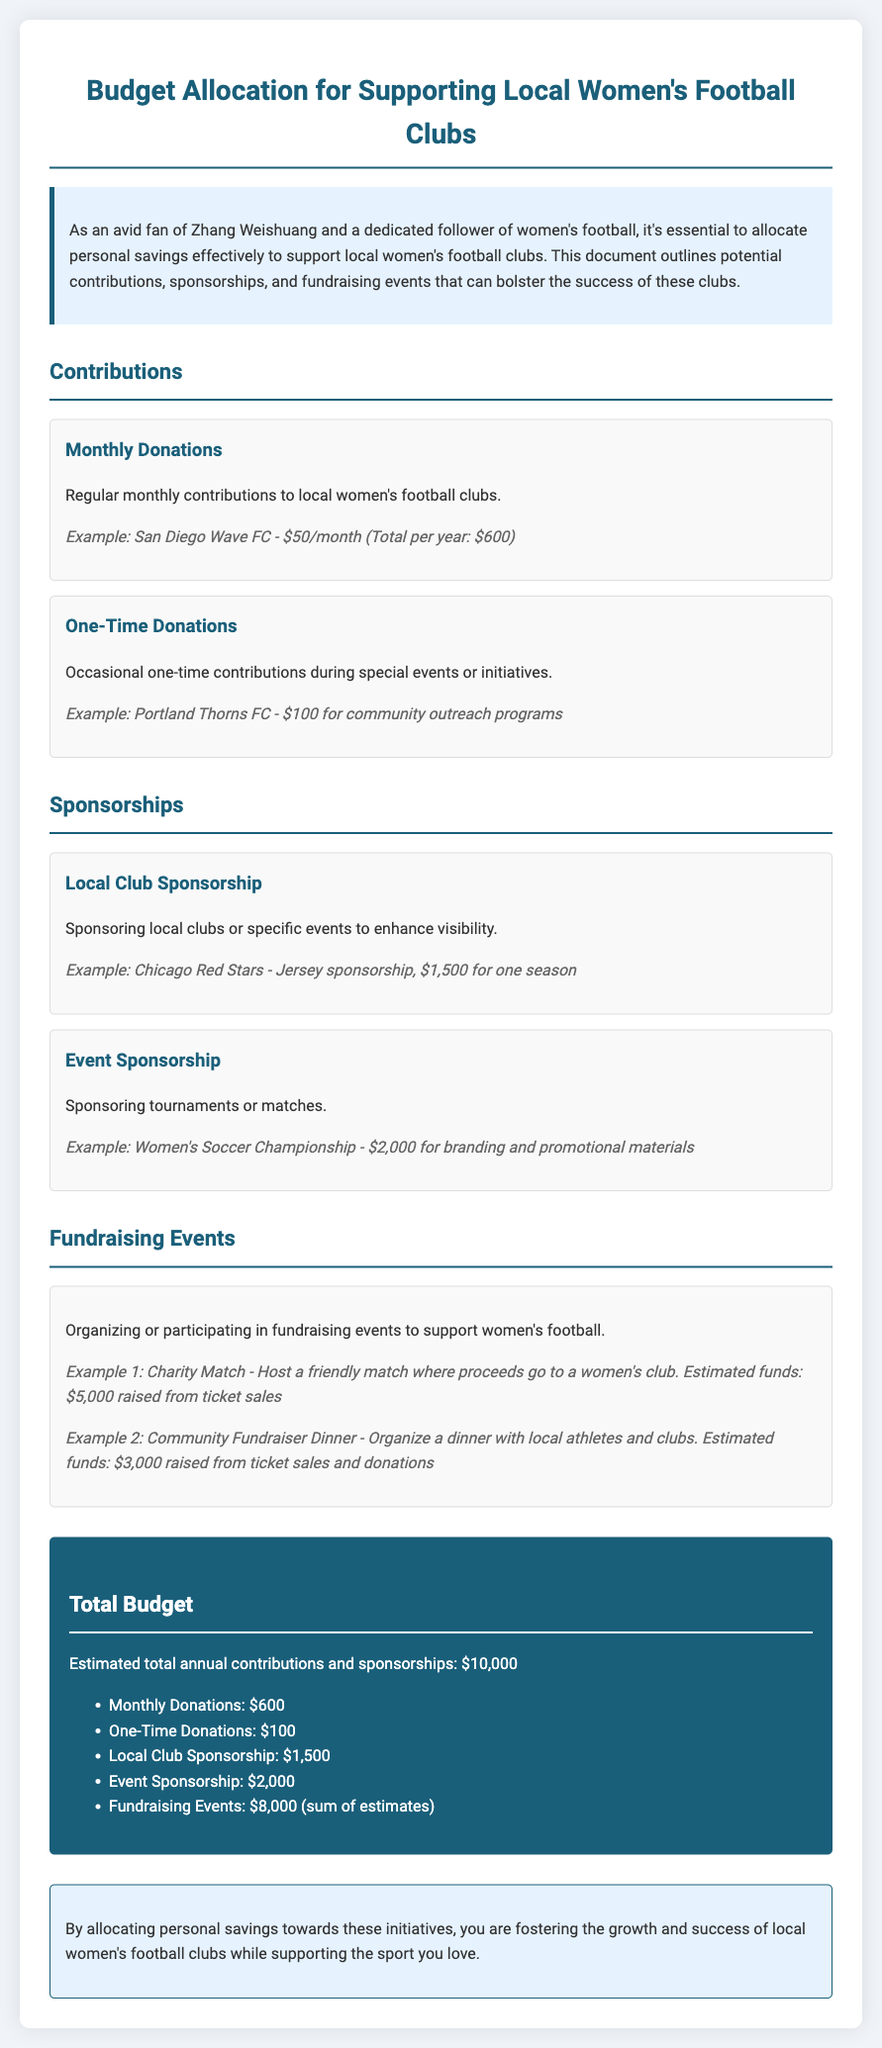What is the purpose of the document? The document outlines potential contributions, sponsorships, and fundraising events to support local women's football clubs.
Answer: Supporting local women's football clubs What is the example amount for monthly donations? The document provides an example of a monthly donation to San Diego Wave FC, which is $50/month.
Answer: $50/month How much is allocated for local club sponsorship? The budget item for local club sponsorship lists an example amount of $1,500 for one season for the Chicago Red Stars.
Answer: $1,500 What is the total estimated annual budget? The total budget section summarizes the total estimated contributions and sponsorships, which is $10,000.
Answer: $10,000 What is the fundraising estimate for a charity match? The document mentions that hosting a charity match could raise an estimated $5,000 from ticket sales.
Answer: $5,000 How much is budgeted for one-time donations? The section on contributions includes one-time donations with an example of $100 for community outreach programs.
Answer: $100 What are the two types of sponsorship mentioned? The sponsorship section specifies 'Local Club Sponsorship' and 'Event Sponsorship' as the two types.
Answer: Local Club Sponsorship and Event Sponsorship What is the total estimated funds from fundraising events? The fundraising events section sums up to an estimated $8,000 raised from all fundraising activities mentioned.
Answer: $8,000 What type of organizations can receive contributions? The document indicates contributions go to local women's football clubs.
Answer: Local women's football clubs 